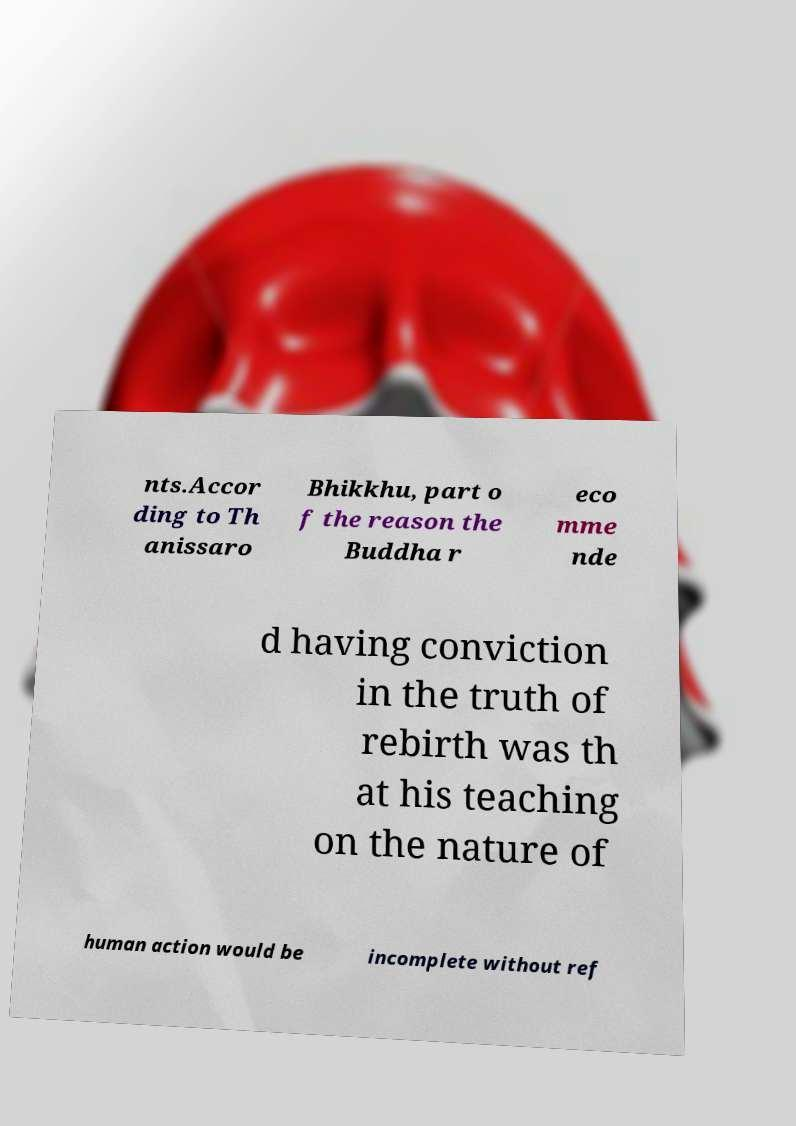For documentation purposes, I need the text within this image transcribed. Could you provide that? nts.Accor ding to Th anissaro Bhikkhu, part o f the reason the Buddha r eco mme nde d having conviction in the truth of rebirth was th at his teaching on the nature of human action would be incomplete without ref 